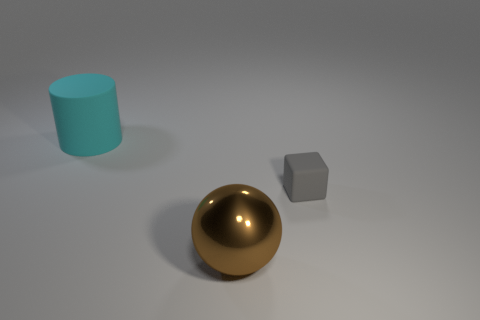Add 2 red rubber objects. How many objects exist? 5 Subtract all purple cylinders. Subtract all red spheres. How many cylinders are left? 1 Subtract all green blocks. How many gray spheres are left? 0 Subtract all gray objects. Subtract all tiny green shiny spheres. How many objects are left? 2 Add 2 gray matte things. How many gray matte things are left? 3 Add 2 blue rubber cubes. How many blue rubber cubes exist? 2 Subtract 0 green spheres. How many objects are left? 3 Subtract all cylinders. How many objects are left? 2 Subtract 1 spheres. How many spheres are left? 0 